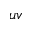Convert formula to latex. <formula><loc_0><loc_0><loc_500><loc_500>u v</formula> 